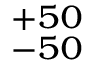Convert formula to latex. <formula><loc_0><loc_0><loc_500><loc_500>^ { + 5 0 } _ { - 5 0 }</formula> 